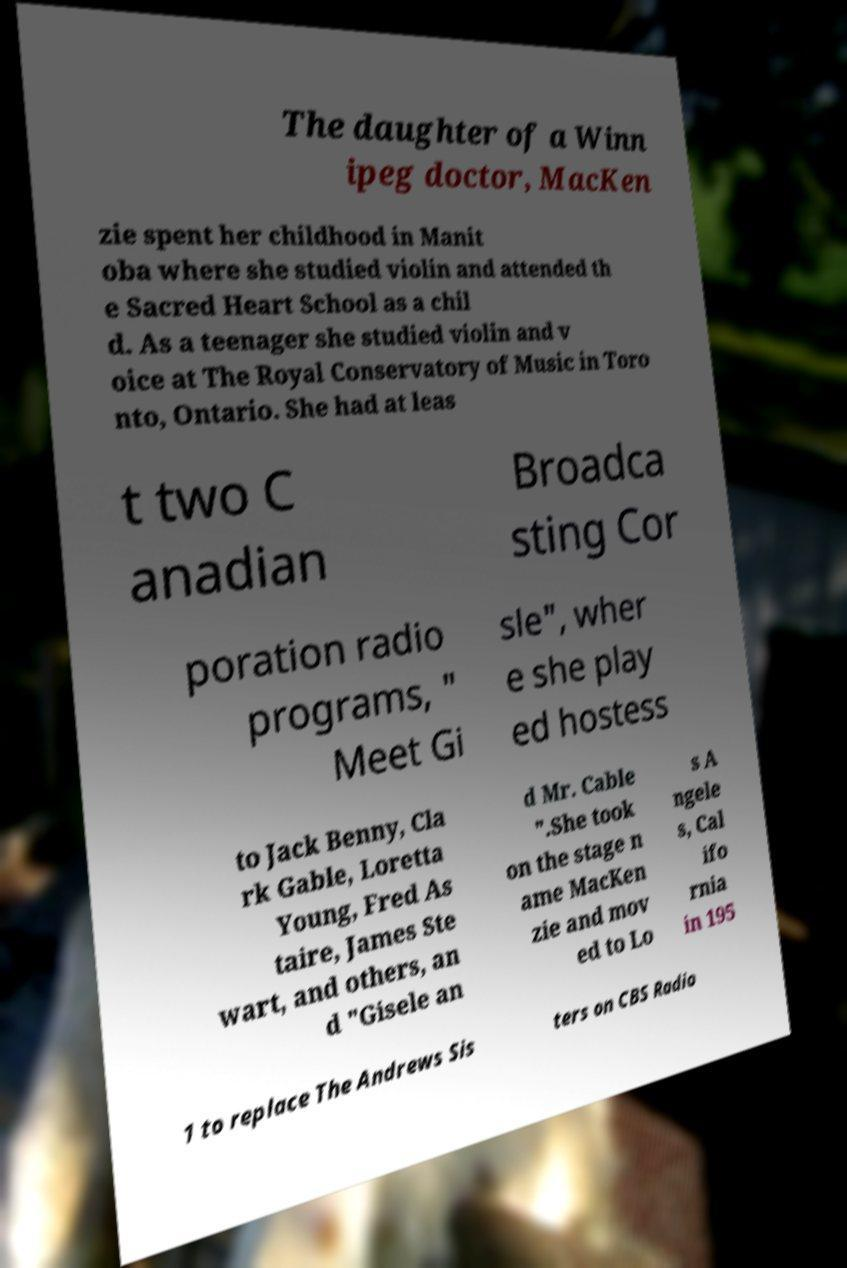I need the written content from this picture converted into text. Can you do that? The daughter of a Winn ipeg doctor, MacKen zie spent her childhood in Manit oba where she studied violin and attended th e Sacred Heart School as a chil d. As a teenager she studied violin and v oice at The Royal Conservatory of Music in Toro nto, Ontario. She had at leas t two C anadian Broadca sting Cor poration radio programs, " Meet Gi sle", wher e she play ed hostess to Jack Benny, Cla rk Gable, Loretta Young, Fred As taire, James Ste wart, and others, an d "Gisele an d Mr. Cable ".She took on the stage n ame MacKen zie and mov ed to Lo s A ngele s, Cal ifo rnia in 195 1 to replace The Andrews Sis ters on CBS Radio 